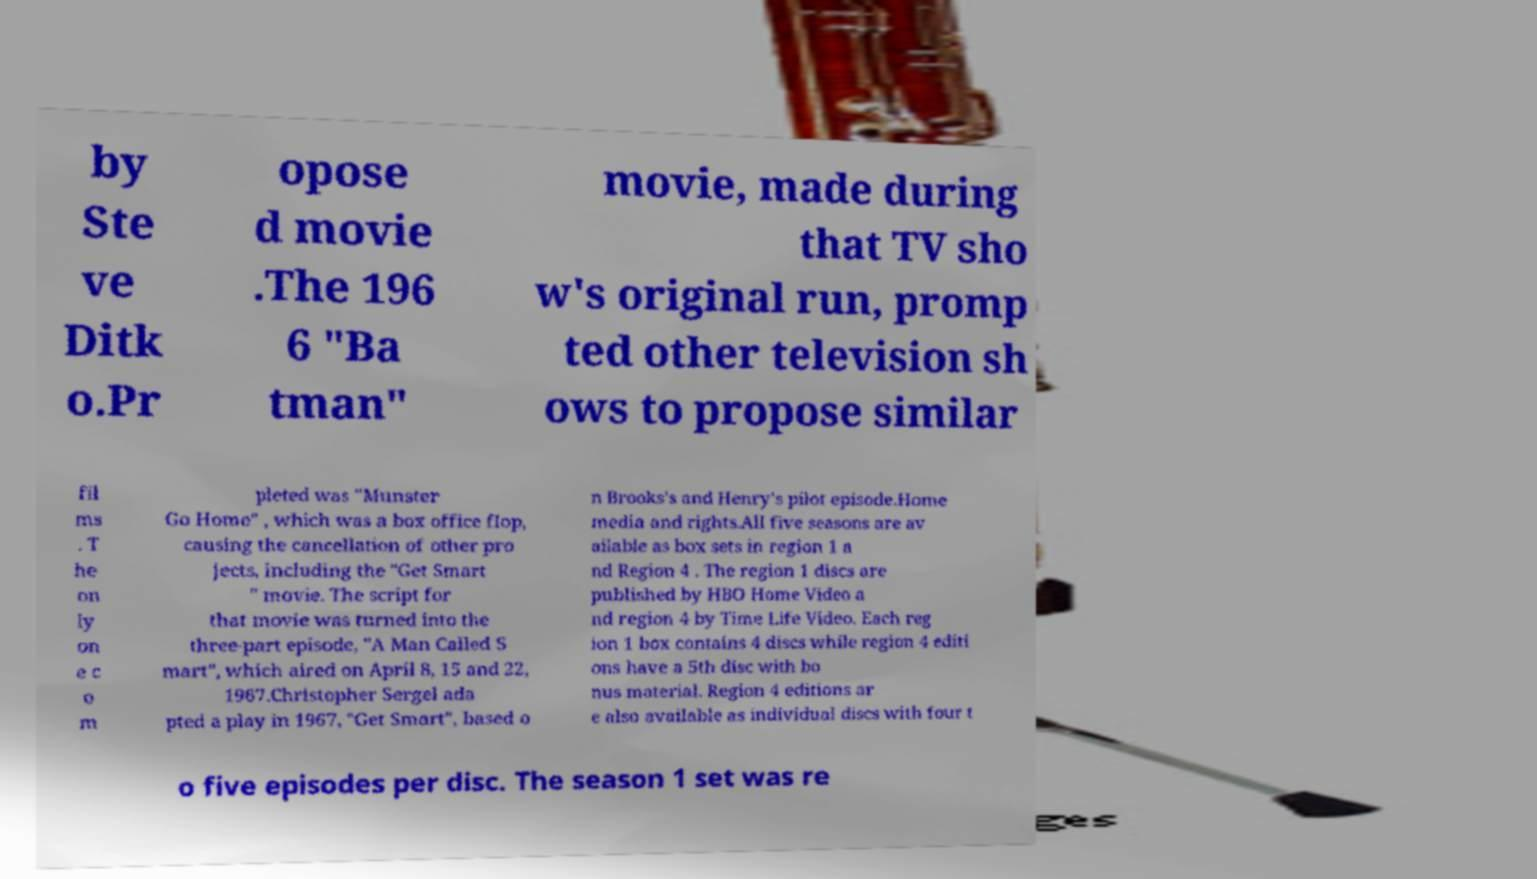Could you extract and type out the text from this image? by Ste ve Ditk o.Pr opose d movie .The 196 6 "Ba tman" movie, made during that TV sho w's original run, promp ted other television sh ows to propose similar fil ms . T he on ly on e c o m pleted was "Munster Go Home" , which was a box office flop, causing the cancellation of other pro jects, including the "Get Smart " movie. The script for that movie was turned into the three-part episode, "A Man Called S mart", which aired on April 8, 15 and 22, 1967.Christopher Sergel ada pted a play in 1967, "Get Smart", based o n Brooks's and Henry's pilot episode.Home media and rights.All five seasons are av ailable as box sets in region 1 a nd Region 4 . The region 1 discs are published by HBO Home Video a nd region 4 by Time Life Video. Each reg ion 1 box contains 4 discs while region 4 editi ons have a 5th disc with bo nus material. Region 4 editions ar e also available as individual discs with four t o five episodes per disc. The season 1 set was re 